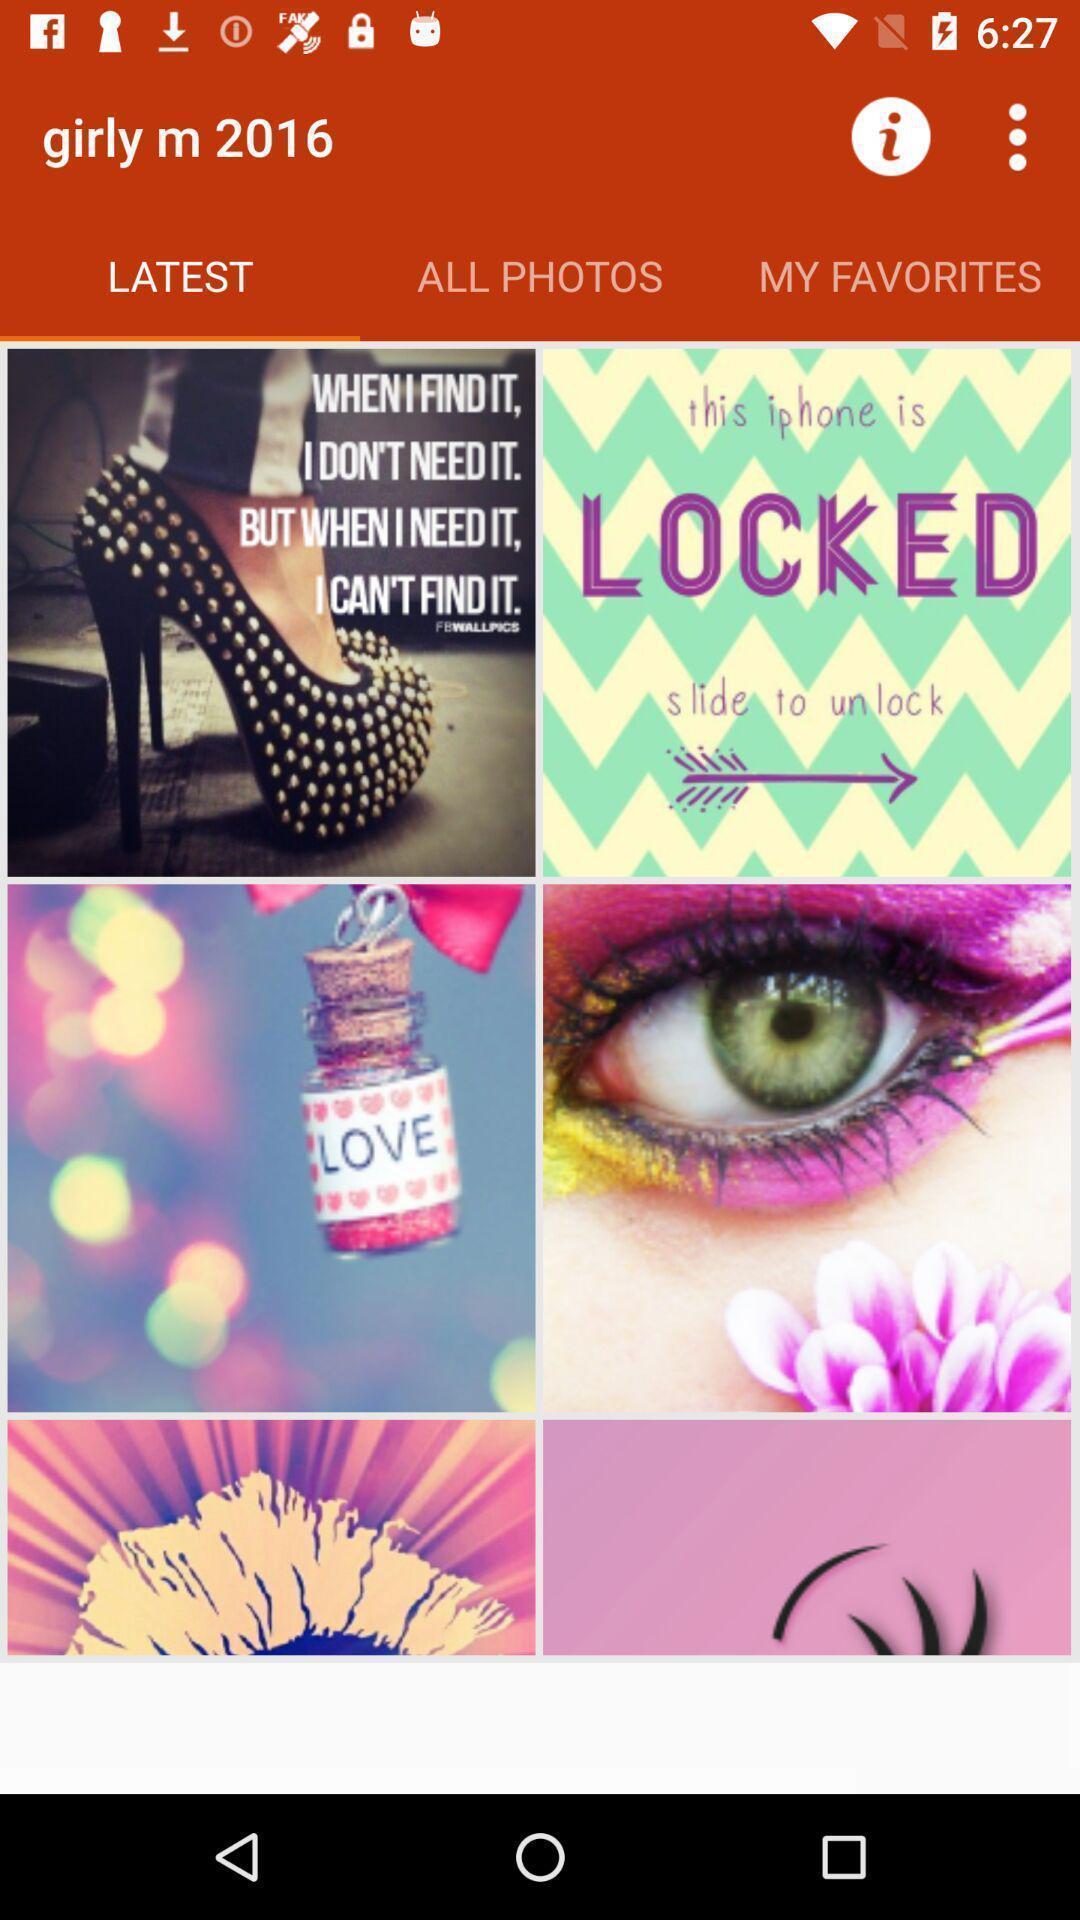Explain the elements present in this screenshot. Page displaying latest photos. 